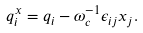Convert formula to latex. <formula><loc_0><loc_0><loc_500><loc_500>q ^ { x } _ { i } = q _ { i } - \omega _ { c } ^ { - 1 } \epsilon _ { i j } x _ { j } .</formula> 